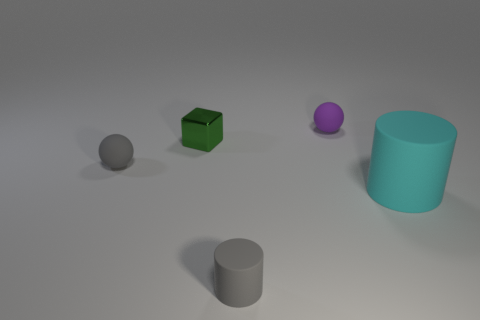There is a cyan cylinder; what number of tiny balls are right of it?
Provide a succinct answer. 0. There is a gray rubber object in front of the cyan matte cylinder; does it have the same size as the green metallic block on the left side of the cyan object?
Provide a succinct answer. Yes. What number of other things are there of the same size as the block?
Ensure brevity in your answer.  3. There is a gray object that is behind the large object that is right of the gray thing on the left side of the green metallic cube; what is its material?
Offer a terse response. Rubber. There is a green block; does it have the same size as the matte ball in front of the tiny purple ball?
Offer a very short reply. Yes. There is a object that is to the right of the tiny gray matte cylinder and to the left of the cyan thing; how big is it?
Your response must be concise. Small. Are there any other metallic blocks of the same color as the small cube?
Give a very brief answer. No. The small rubber object that is on the right side of the rubber thing in front of the large cylinder is what color?
Offer a very short reply. Purple. Are there fewer green things that are behind the small green metallic object than cyan cylinders right of the large cyan cylinder?
Give a very brief answer. No. Does the purple object have the same size as the green shiny cube?
Your answer should be very brief. Yes. 